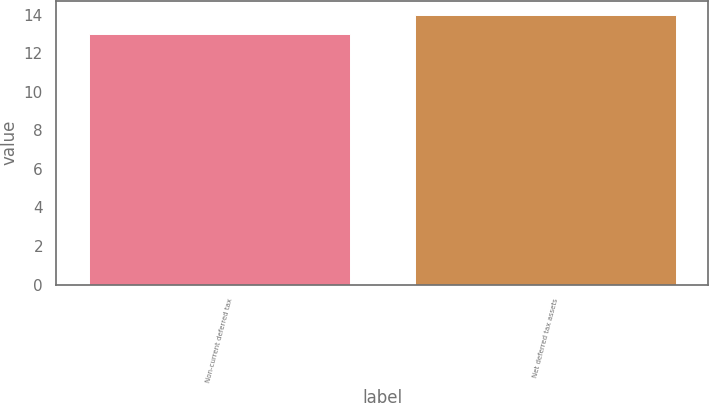<chart> <loc_0><loc_0><loc_500><loc_500><bar_chart><fcel>Non-current deferred tax<fcel>Net deferred tax assets<nl><fcel>13<fcel>14<nl></chart> 